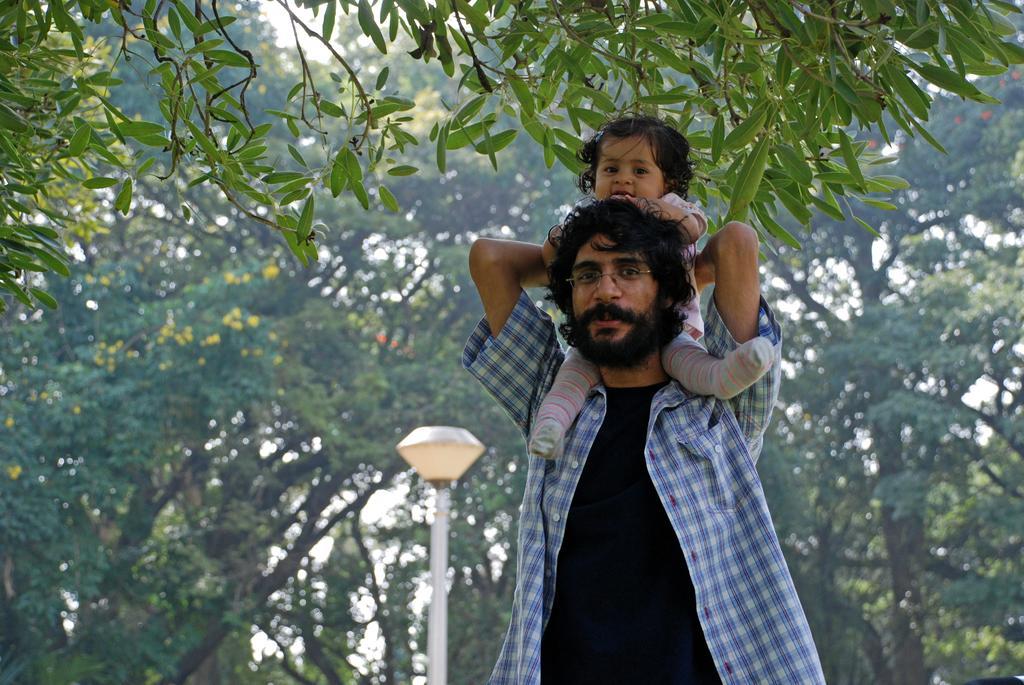Describe this image in one or two sentences. In this picture we can see a man and a baby, behind him we can see a pole, light and few trees. 